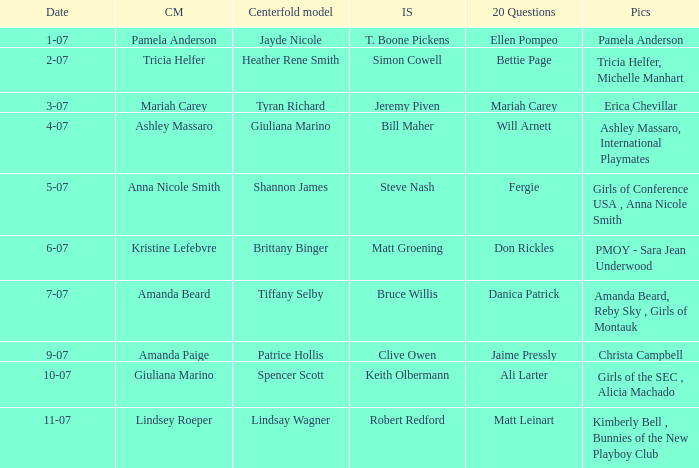Who was the centerfold model when the issue's pictorial was kimberly bell , bunnies of the new playboy club? Lindsay Wagner. 